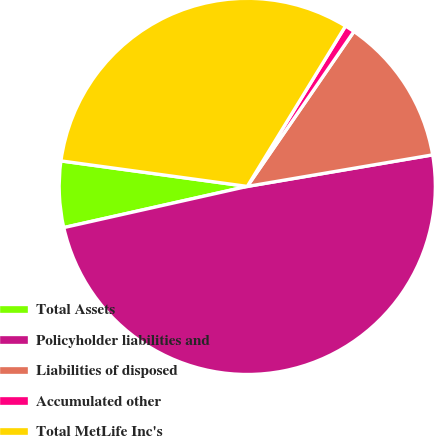Convert chart. <chart><loc_0><loc_0><loc_500><loc_500><pie_chart><fcel>Total Assets<fcel>Policyholder liabilities and<fcel>Liabilities of disposed<fcel>Accumulated other<fcel>Total MetLife Inc's<nl><fcel>5.68%<fcel>49.17%<fcel>12.72%<fcel>0.85%<fcel>31.58%<nl></chart> 